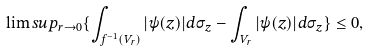<formula> <loc_0><loc_0><loc_500><loc_500>\lim s u p _ { r \to 0 } \{ \int _ { f ^ { - 1 } ( V _ { r } ) } | \psi ( z ) | d \sigma _ { z } - \int _ { V _ { r } } | \psi ( z ) | d \sigma _ { z } \} \leq 0 ,</formula> 